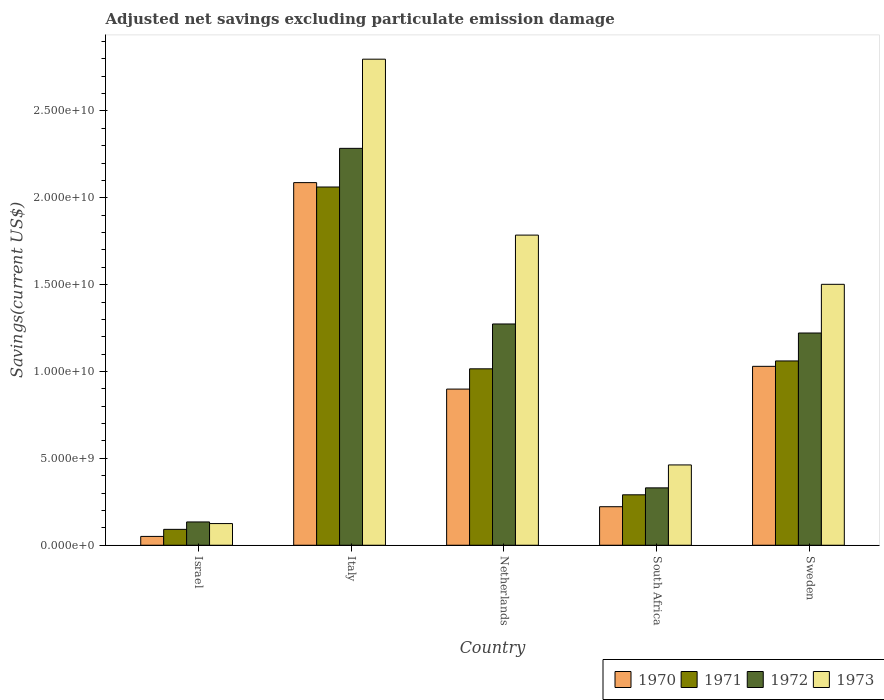Are the number of bars per tick equal to the number of legend labels?
Offer a terse response. Yes. Are the number of bars on each tick of the X-axis equal?
Your answer should be very brief. Yes. How many bars are there on the 2nd tick from the left?
Provide a succinct answer. 4. How many bars are there on the 2nd tick from the right?
Your response must be concise. 4. What is the label of the 5th group of bars from the left?
Offer a very short reply. Sweden. In how many cases, is the number of bars for a given country not equal to the number of legend labels?
Offer a very short reply. 0. What is the adjusted net savings in 1972 in Sweden?
Provide a short and direct response. 1.22e+1. Across all countries, what is the maximum adjusted net savings in 1970?
Provide a short and direct response. 2.09e+1. Across all countries, what is the minimum adjusted net savings in 1971?
Offer a terse response. 9.14e+08. What is the total adjusted net savings in 1973 in the graph?
Provide a succinct answer. 6.67e+1. What is the difference between the adjusted net savings in 1973 in Italy and that in South Africa?
Offer a very short reply. 2.34e+1. What is the difference between the adjusted net savings in 1972 in Israel and the adjusted net savings in 1970 in South Africa?
Provide a short and direct response. -8.77e+08. What is the average adjusted net savings in 1973 per country?
Your response must be concise. 1.33e+1. What is the difference between the adjusted net savings of/in 1972 and adjusted net savings of/in 1973 in Israel?
Provide a short and direct response. 9.40e+07. What is the ratio of the adjusted net savings in 1971 in South Africa to that in Sweden?
Give a very brief answer. 0.27. What is the difference between the highest and the second highest adjusted net savings in 1971?
Keep it short and to the point. -1.00e+1. What is the difference between the highest and the lowest adjusted net savings in 1972?
Your response must be concise. 2.15e+1. Is it the case that in every country, the sum of the adjusted net savings in 1971 and adjusted net savings in 1972 is greater than the sum of adjusted net savings in 1970 and adjusted net savings in 1973?
Make the answer very short. No. Is it the case that in every country, the sum of the adjusted net savings in 1971 and adjusted net savings in 1973 is greater than the adjusted net savings in 1970?
Make the answer very short. Yes. How many bars are there?
Offer a very short reply. 20. Are all the bars in the graph horizontal?
Ensure brevity in your answer.  No. How many countries are there in the graph?
Ensure brevity in your answer.  5. What is the difference between two consecutive major ticks on the Y-axis?
Offer a very short reply. 5.00e+09. Does the graph contain any zero values?
Provide a short and direct response. No. Does the graph contain grids?
Your answer should be compact. No. Where does the legend appear in the graph?
Provide a short and direct response. Bottom right. How are the legend labels stacked?
Your answer should be compact. Horizontal. What is the title of the graph?
Offer a terse response. Adjusted net savings excluding particulate emission damage. What is the label or title of the Y-axis?
Your answer should be compact. Savings(current US$). What is the Savings(current US$) in 1970 in Israel?
Offer a very short reply. 5.08e+08. What is the Savings(current US$) of 1971 in Israel?
Make the answer very short. 9.14e+08. What is the Savings(current US$) of 1972 in Israel?
Offer a very short reply. 1.34e+09. What is the Savings(current US$) in 1973 in Israel?
Offer a terse response. 1.25e+09. What is the Savings(current US$) of 1970 in Italy?
Provide a short and direct response. 2.09e+1. What is the Savings(current US$) of 1971 in Italy?
Make the answer very short. 2.06e+1. What is the Savings(current US$) of 1972 in Italy?
Ensure brevity in your answer.  2.28e+1. What is the Savings(current US$) of 1973 in Italy?
Ensure brevity in your answer.  2.80e+1. What is the Savings(current US$) in 1970 in Netherlands?
Offer a terse response. 8.99e+09. What is the Savings(current US$) in 1971 in Netherlands?
Your response must be concise. 1.02e+1. What is the Savings(current US$) in 1972 in Netherlands?
Your response must be concise. 1.27e+1. What is the Savings(current US$) in 1973 in Netherlands?
Offer a very short reply. 1.79e+1. What is the Savings(current US$) in 1970 in South Africa?
Your answer should be very brief. 2.22e+09. What is the Savings(current US$) in 1971 in South Africa?
Provide a short and direct response. 2.90e+09. What is the Savings(current US$) in 1972 in South Africa?
Your response must be concise. 3.30e+09. What is the Savings(current US$) in 1973 in South Africa?
Offer a very short reply. 4.62e+09. What is the Savings(current US$) of 1970 in Sweden?
Ensure brevity in your answer.  1.03e+1. What is the Savings(current US$) in 1971 in Sweden?
Offer a very short reply. 1.06e+1. What is the Savings(current US$) of 1972 in Sweden?
Provide a short and direct response. 1.22e+1. What is the Savings(current US$) in 1973 in Sweden?
Give a very brief answer. 1.50e+1. Across all countries, what is the maximum Savings(current US$) of 1970?
Your answer should be very brief. 2.09e+1. Across all countries, what is the maximum Savings(current US$) in 1971?
Keep it short and to the point. 2.06e+1. Across all countries, what is the maximum Savings(current US$) of 1972?
Ensure brevity in your answer.  2.28e+1. Across all countries, what is the maximum Savings(current US$) of 1973?
Your answer should be very brief. 2.80e+1. Across all countries, what is the minimum Savings(current US$) of 1970?
Offer a terse response. 5.08e+08. Across all countries, what is the minimum Savings(current US$) of 1971?
Give a very brief answer. 9.14e+08. Across all countries, what is the minimum Savings(current US$) in 1972?
Your response must be concise. 1.34e+09. Across all countries, what is the minimum Savings(current US$) of 1973?
Keep it short and to the point. 1.25e+09. What is the total Savings(current US$) of 1970 in the graph?
Make the answer very short. 4.29e+1. What is the total Savings(current US$) of 1971 in the graph?
Provide a succinct answer. 4.52e+1. What is the total Savings(current US$) in 1972 in the graph?
Provide a succinct answer. 5.24e+1. What is the total Savings(current US$) in 1973 in the graph?
Ensure brevity in your answer.  6.67e+1. What is the difference between the Savings(current US$) of 1970 in Israel and that in Italy?
Give a very brief answer. -2.04e+1. What is the difference between the Savings(current US$) of 1971 in Israel and that in Italy?
Provide a succinct answer. -1.97e+1. What is the difference between the Savings(current US$) in 1972 in Israel and that in Italy?
Offer a terse response. -2.15e+1. What is the difference between the Savings(current US$) of 1973 in Israel and that in Italy?
Provide a succinct answer. -2.67e+1. What is the difference between the Savings(current US$) in 1970 in Israel and that in Netherlands?
Provide a succinct answer. -8.48e+09. What is the difference between the Savings(current US$) of 1971 in Israel and that in Netherlands?
Ensure brevity in your answer.  -9.24e+09. What is the difference between the Savings(current US$) of 1972 in Israel and that in Netherlands?
Your answer should be very brief. -1.14e+1. What is the difference between the Savings(current US$) of 1973 in Israel and that in Netherlands?
Offer a terse response. -1.66e+1. What is the difference between the Savings(current US$) of 1970 in Israel and that in South Africa?
Your answer should be very brief. -1.71e+09. What is the difference between the Savings(current US$) of 1971 in Israel and that in South Africa?
Keep it short and to the point. -1.99e+09. What is the difference between the Savings(current US$) in 1972 in Israel and that in South Africa?
Make the answer very short. -1.96e+09. What is the difference between the Savings(current US$) of 1973 in Israel and that in South Africa?
Offer a terse response. -3.38e+09. What is the difference between the Savings(current US$) in 1970 in Israel and that in Sweden?
Provide a succinct answer. -9.79e+09. What is the difference between the Savings(current US$) of 1971 in Israel and that in Sweden?
Your response must be concise. -9.69e+09. What is the difference between the Savings(current US$) of 1972 in Israel and that in Sweden?
Offer a very short reply. -1.09e+1. What is the difference between the Savings(current US$) of 1973 in Israel and that in Sweden?
Your answer should be compact. -1.38e+1. What is the difference between the Savings(current US$) of 1970 in Italy and that in Netherlands?
Your response must be concise. 1.19e+1. What is the difference between the Savings(current US$) in 1971 in Italy and that in Netherlands?
Offer a terse response. 1.05e+1. What is the difference between the Savings(current US$) in 1972 in Italy and that in Netherlands?
Your answer should be compact. 1.01e+1. What is the difference between the Savings(current US$) in 1973 in Italy and that in Netherlands?
Ensure brevity in your answer.  1.01e+1. What is the difference between the Savings(current US$) of 1970 in Italy and that in South Africa?
Make the answer very short. 1.87e+1. What is the difference between the Savings(current US$) of 1971 in Italy and that in South Africa?
Your answer should be very brief. 1.77e+1. What is the difference between the Savings(current US$) of 1972 in Italy and that in South Africa?
Your answer should be compact. 1.95e+1. What is the difference between the Savings(current US$) of 1973 in Italy and that in South Africa?
Your response must be concise. 2.34e+1. What is the difference between the Savings(current US$) in 1970 in Italy and that in Sweden?
Provide a succinct answer. 1.06e+1. What is the difference between the Savings(current US$) of 1971 in Italy and that in Sweden?
Provide a short and direct response. 1.00e+1. What is the difference between the Savings(current US$) in 1972 in Italy and that in Sweden?
Your answer should be compact. 1.06e+1. What is the difference between the Savings(current US$) in 1973 in Italy and that in Sweden?
Give a very brief answer. 1.30e+1. What is the difference between the Savings(current US$) of 1970 in Netherlands and that in South Africa?
Offer a terse response. 6.77e+09. What is the difference between the Savings(current US$) of 1971 in Netherlands and that in South Africa?
Provide a succinct answer. 7.25e+09. What is the difference between the Savings(current US$) of 1972 in Netherlands and that in South Africa?
Your answer should be compact. 9.43e+09. What is the difference between the Savings(current US$) of 1973 in Netherlands and that in South Africa?
Make the answer very short. 1.32e+1. What is the difference between the Savings(current US$) in 1970 in Netherlands and that in Sweden?
Keep it short and to the point. -1.31e+09. What is the difference between the Savings(current US$) of 1971 in Netherlands and that in Sweden?
Offer a very short reply. -4.54e+08. What is the difference between the Savings(current US$) in 1972 in Netherlands and that in Sweden?
Provide a short and direct response. 5.20e+08. What is the difference between the Savings(current US$) in 1973 in Netherlands and that in Sweden?
Your answer should be very brief. 2.83e+09. What is the difference between the Savings(current US$) of 1970 in South Africa and that in Sweden?
Your response must be concise. -8.08e+09. What is the difference between the Savings(current US$) in 1971 in South Africa and that in Sweden?
Your answer should be very brief. -7.70e+09. What is the difference between the Savings(current US$) in 1972 in South Africa and that in Sweden?
Your answer should be very brief. -8.91e+09. What is the difference between the Savings(current US$) of 1973 in South Africa and that in Sweden?
Your response must be concise. -1.04e+1. What is the difference between the Savings(current US$) of 1970 in Israel and the Savings(current US$) of 1971 in Italy?
Offer a very short reply. -2.01e+1. What is the difference between the Savings(current US$) of 1970 in Israel and the Savings(current US$) of 1972 in Italy?
Your response must be concise. -2.23e+1. What is the difference between the Savings(current US$) in 1970 in Israel and the Savings(current US$) in 1973 in Italy?
Offer a terse response. -2.75e+1. What is the difference between the Savings(current US$) in 1971 in Israel and the Savings(current US$) in 1972 in Italy?
Offer a very short reply. -2.19e+1. What is the difference between the Savings(current US$) of 1971 in Israel and the Savings(current US$) of 1973 in Italy?
Your answer should be compact. -2.71e+1. What is the difference between the Savings(current US$) of 1972 in Israel and the Savings(current US$) of 1973 in Italy?
Keep it short and to the point. -2.66e+1. What is the difference between the Savings(current US$) of 1970 in Israel and the Savings(current US$) of 1971 in Netherlands?
Your answer should be compact. -9.65e+09. What is the difference between the Savings(current US$) in 1970 in Israel and the Savings(current US$) in 1972 in Netherlands?
Make the answer very short. -1.22e+1. What is the difference between the Savings(current US$) in 1970 in Israel and the Savings(current US$) in 1973 in Netherlands?
Your response must be concise. -1.73e+1. What is the difference between the Savings(current US$) of 1971 in Israel and the Savings(current US$) of 1972 in Netherlands?
Offer a terse response. -1.18e+1. What is the difference between the Savings(current US$) in 1971 in Israel and the Savings(current US$) in 1973 in Netherlands?
Your answer should be compact. -1.69e+1. What is the difference between the Savings(current US$) in 1972 in Israel and the Savings(current US$) in 1973 in Netherlands?
Your answer should be compact. -1.65e+1. What is the difference between the Savings(current US$) in 1970 in Israel and the Savings(current US$) in 1971 in South Africa?
Offer a terse response. -2.39e+09. What is the difference between the Savings(current US$) of 1970 in Israel and the Savings(current US$) of 1972 in South Africa?
Your response must be concise. -2.79e+09. What is the difference between the Savings(current US$) of 1970 in Israel and the Savings(current US$) of 1973 in South Africa?
Ensure brevity in your answer.  -4.11e+09. What is the difference between the Savings(current US$) in 1971 in Israel and the Savings(current US$) in 1972 in South Africa?
Ensure brevity in your answer.  -2.39e+09. What is the difference between the Savings(current US$) in 1971 in Israel and the Savings(current US$) in 1973 in South Africa?
Offer a very short reply. -3.71e+09. What is the difference between the Savings(current US$) of 1972 in Israel and the Savings(current US$) of 1973 in South Africa?
Offer a terse response. -3.28e+09. What is the difference between the Savings(current US$) in 1970 in Israel and the Savings(current US$) in 1971 in Sweden?
Your answer should be compact. -1.01e+1. What is the difference between the Savings(current US$) of 1970 in Israel and the Savings(current US$) of 1972 in Sweden?
Offer a very short reply. -1.17e+1. What is the difference between the Savings(current US$) in 1970 in Israel and the Savings(current US$) in 1973 in Sweden?
Ensure brevity in your answer.  -1.45e+1. What is the difference between the Savings(current US$) in 1971 in Israel and the Savings(current US$) in 1972 in Sweden?
Your answer should be compact. -1.13e+1. What is the difference between the Savings(current US$) of 1971 in Israel and the Savings(current US$) of 1973 in Sweden?
Your answer should be compact. -1.41e+1. What is the difference between the Savings(current US$) of 1972 in Israel and the Savings(current US$) of 1973 in Sweden?
Give a very brief answer. -1.37e+1. What is the difference between the Savings(current US$) of 1970 in Italy and the Savings(current US$) of 1971 in Netherlands?
Give a very brief answer. 1.07e+1. What is the difference between the Savings(current US$) of 1970 in Italy and the Savings(current US$) of 1972 in Netherlands?
Ensure brevity in your answer.  8.14e+09. What is the difference between the Savings(current US$) in 1970 in Italy and the Savings(current US$) in 1973 in Netherlands?
Your answer should be compact. 3.02e+09. What is the difference between the Savings(current US$) in 1971 in Italy and the Savings(current US$) in 1972 in Netherlands?
Offer a terse response. 7.88e+09. What is the difference between the Savings(current US$) in 1971 in Italy and the Savings(current US$) in 1973 in Netherlands?
Your answer should be very brief. 2.77e+09. What is the difference between the Savings(current US$) of 1972 in Italy and the Savings(current US$) of 1973 in Netherlands?
Give a very brief answer. 4.99e+09. What is the difference between the Savings(current US$) of 1970 in Italy and the Savings(current US$) of 1971 in South Africa?
Offer a very short reply. 1.80e+1. What is the difference between the Savings(current US$) of 1970 in Italy and the Savings(current US$) of 1972 in South Africa?
Your response must be concise. 1.76e+1. What is the difference between the Savings(current US$) of 1970 in Italy and the Savings(current US$) of 1973 in South Africa?
Your answer should be compact. 1.62e+1. What is the difference between the Savings(current US$) in 1971 in Italy and the Savings(current US$) in 1972 in South Africa?
Provide a succinct answer. 1.73e+1. What is the difference between the Savings(current US$) in 1971 in Italy and the Savings(current US$) in 1973 in South Africa?
Provide a short and direct response. 1.60e+1. What is the difference between the Savings(current US$) of 1972 in Italy and the Savings(current US$) of 1973 in South Africa?
Your response must be concise. 1.82e+1. What is the difference between the Savings(current US$) of 1970 in Italy and the Savings(current US$) of 1971 in Sweden?
Provide a succinct answer. 1.03e+1. What is the difference between the Savings(current US$) in 1970 in Italy and the Savings(current US$) in 1972 in Sweden?
Provide a short and direct response. 8.66e+09. What is the difference between the Savings(current US$) of 1970 in Italy and the Savings(current US$) of 1973 in Sweden?
Provide a short and direct response. 5.85e+09. What is the difference between the Savings(current US$) in 1971 in Italy and the Savings(current US$) in 1972 in Sweden?
Provide a succinct answer. 8.40e+09. What is the difference between the Savings(current US$) in 1971 in Italy and the Savings(current US$) in 1973 in Sweden?
Offer a very short reply. 5.60e+09. What is the difference between the Savings(current US$) in 1972 in Italy and the Savings(current US$) in 1973 in Sweden?
Your response must be concise. 7.83e+09. What is the difference between the Savings(current US$) in 1970 in Netherlands and the Savings(current US$) in 1971 in South Africa?
Ensure brevity in your answer.  6.09e+09. What is the difference between the Savings(current US$) in 1970 in Netherlands and the Savings(current US$) in 1972 in South Africa?
Keep it short and to the point. 5.69e+09. What is the difference between the Savings(current US$) of 1970 in Netherlands and the Savings(current US$) of 1973 in South Africa?
Provide a short and direct response. 4.37e+09. What is the difference between the Savings(current US$) in 1971 in Netherlands and the Savings(current US$) in 1972 in South Africa?
Provide a succinct answer. 6.85e+09. What is the difference between the Savings(current US$) in 1971 in Netherlands and the Savings(current US$) in 1973 in South Africa?
Your answer should be compact. 5.53e+09. What is the difference between the Savings(current US$) of 1972 in Netherlands and the Savings(current US$) of 1973 in South Africa?
Offer a very short reply. 8.11e+09. What is the difference between the Savings(current US$) in 1970 in Netherlands and the Savings(current US$) in 1971 in Sweden?
Your answer should be compact. -1.62e+09. What is the difference between the Savings(current US$) of 1970 in Netherlands and the Savings(current US$) of 1972 in Sweden?
Give a very brief answer. -3.23e+09. What is the difference between the Savings(current US$) of 1970 in Netherlands and the Savings(current US$) of 1973 in Sweden?
Give a very brief answer. -6.03e+09. What is the difference between the Savings(current US$) of 1971 in Netherlands and the Savings(current US$) of 1972 in Sweden?
Your response must be concise. -2.06e+09. What is the difference between the Savings(current US$) of 1971 in Netherlands and the Savings(current US$) of 1973 in Sweden?
Make the answer very short. -4.86e+09. What is the difference between the Savings(current US$) of 1972 in Netherlands and the Savings(current US$) of 1973 in Sweden?
Keep it short and to the point. -2.28e+09. What is the difference between the Savings(current US$) in 1970 in South Africa and the Savings(current US$) in 1971 in Sweden?
Your answer should be very brief. -8.39e+09. What is the difference between the Savings(current US$) in 1970 in South Africa and the Savings(current US$) in 1972 in Sweden?
Your response must be concise. -1.00e+1. What is the difference between the Savings(current US$) in 1970 in South Africa and the Savings(current US$) in 1973 in Sweden?
Give a very brief answer. -1.28e+1. What is the difference between the Savings(current US$) in 1971 in South Africa and the Savings(current US$) in 1972 in Sweden?
Your answer should be compact. -9.31e+09. What is the difference between the Savings(current US$) of 1971 in South Africa and the Savings(current US$) of 1973 in Sweden?
Your answer should be compact. -1.21e+1. What is the difference between the Savings(current US$) in 1972 in South Africa and the Savings(current US$) in 1973 in Sweden?
Offer a terse response. -1.17e+1. What is the average Savings(current US$) of 1970 per country?
Offer a terse response. 8.58e+09. What is the average Savings(current US$) in 1971 per country?
Provide a short and direct response. 9.04e+09. What is the average Savings(current US$) in 1972 per country?
Ensure brevity in your answer.  1.05e+1. What is the average Savings(current US$) in 1973 per country?
Offer a terse response. 1.33e+1. What is the difference between the Savings(current US$) in 1970 and Savings(current US$) in 1971 in Israel?
Your answer should be very brief. -4.06e+08. What is the difference between the Savings(current US$) in 1970 and Savings(current US$) in 1972 in Israel?
Keep it short and to the point. -8.33e+08. What is the difference between the Savings(current US$) of 1970 and Savings(current US$) of 1973 in Israel?
Ensure brevity in your answer.  -7.39e+08. What is the difference between the Savings(current US$) in 1971 and Savings(current US$) in 1972 in Israel?
Your answer should be compact. -4.27e+08. What is the difference between the Savings(current US$) in 1971 and Savings(current US$) in 1973 in Israel?
Make the answer very short. -3.33e+08. What is the difference between the Savings(current US$) of 1972 and Savings(current US$) of 1973 in Israel?
Give a very brief answer. 9.40e+07. What is the difference between the Savings(current US$) of 1970 and Savings(current US$) of 1971 in Italy?
Your answer should be compact. 2.53e+08. What is the difference between the Savings(current US$) in 1970 and Savings(current US$) in 1972 in Italy?
Give a very brief answer. -1.97e+09. What is the difference between the Savings(current US$) of 1970 and Savings(current US$) of 1973 in Italy?
Offer a very short reply. -7.11e+09. What is the difference between the Savings(current US$) of 1971 and Savings(current US$) of 1972 in Italy?
Offer a terse response. -2.23e+09. What is the difference between the Savings(current US$) in 1971 and Savings(current US$) in 1973 in Italy?
Ensure brevity in your answer.  -7.36e+09. What is the difference between the Savings(current US$) in 1972 and Savings(current US$) in 1973 in Italy?
Provide a succinct answer. -5.13e+09. What is the difference between the Savings(current US$) of 1970 and Savings(current US$) of 1971 in Netherlands?
Ensure brevity in your answer.  -1.17e+09. What is the difference between the Savings(current US$) in 1970 and Savings(current US$) in 1972 in Netherlands?
Make the answer very short. -3.75e+09. What is the difference between the Savings(current US$) of 1970 and Savings(current US$) of 1973 in Netherlands?
Keep it short and to the point. -8.86e+09. What is the difference between the Savings(current US$) in 1971 and Savings(current US$) in 1972 in Netherlands?
Provide a succinct answer. -2.58e+09. What is the difference between the Savings(current US$) of 1971 and Savings(current US$) of 1973 in Netherlands?
Make the answer very short. -7.70e+09. What is the difference between the Savings(current US$) of 1972 and Savings(current US$) of 1973 in Netherlands?
Give a very brief answer. -5.11e+09. What is the difference between the Savings(current US$) of 1970 and Savings(current US$) of 1971 in South Africa?
Give a very brief answer. -6.85e+08. What is the difference between the Savings(current US$) in 1970 and Savings(current US$) in 1972 in South Africa?
Provide a short and direct response. -1.08e+09. What is the difference between the Savings(current US$) of 1970 and Savings(current US$) of 1973 in South Africa?
Your answer should be very brief. -2.40e+09. What is the difference between the Savings(current US$) of 1971 and Savings(current US$) of 1972 in South Africa?
Offer a very short reply. -4.00e+08. What is the difference between the Savings(current US$) of 1971 and Savings(current US$) of 1973 in South Africa?
Ensure brevity in your answer.  -1.72e+09. What is the difference between the Savings(current US$) in 1972 and Savings(current US$) in 1973 in South Africa?
Offer a very short reply. -1.32e+09. What is the difference between the Savings(current US$) of 1970 and Savings(current US$) of 1971 in Sweden?
Provide a succinct answer. -3.10e+08. What is the difference between the Savings(current US$) in 1970 and Savings(current US$) in 1972 in Sweden?
Give a very brief answer. -1.92e+09. What is the difference between the Savings(current US$) of 1970 and Savings(current US$) of 1973 in Sweden?
Offer a terse response. -4.72e+09. What is the difference between the Savings(current US$) in 1971 and Savings(current US$) in 1972 in Sweden?
Offer a very short reply. -1.61e+09. What is the difference between the Savings(current US$) of 1971 and Savings(current US$) of 1973 in Sweden?
Offer a terse response. -4.41e+09. What is the difference between the Savings(current US$) in 1972 and Savings(current US$) in 1973 in Sweden?
Offer a terse response. -2.80e+09. What is the ratio of the Savings(current US$) of 1970 in Israel to that in Italy?
Provide a succinct answer. 0.02. What is the ratio of the Savings(current US$) of 1971 in Israel to that in Italy?
Provide a short and direct response. 0.04. What is the ratio of the Savings(current US$) in 1972 in Israel to that in Italy?
Make the answer very short. 0.06. What is the ratio of the Savings(current US$) in 1973 in Israel to that in Italy?
Ensure brevity in your answer.  0.04. What is the ratio of the Savings(current US$) of 1970 in Israel to that in Netherlands?
Provide a short and direct response. 0.06. What is the ratio of the Savings(current US$) in 1971 in Israel to that in Netherlands?
Provide a succinct answer. 0.09. What is the ratio of the Savings(current US$) of 1972 in Israel to that in Netherlands?
Your answer should be very brief. 0.11. What is the ratio of the Savings(current US$) in 1973 in Israel to that in Netherlands?
Keep it short and to the point. 0.07. What is the ratio of the Savings(current US$) in 1970 in Israel to that in South Africa?
Your answer should be very brief. 0.23. What is the ratio of the Savings(current US$) in 1971 in Israel to that in South Africa?
Give a very brief answer. 0.32. What is the ratio of the Savings(current US$) in 1972 in Israel to that in South Africa?
Keep it short and to the point. 0.41. What is the ratio of the Savings(current US$) in 1973 in Israel to that in South Africa?
Offer a very short reply. 0.27. What is the ratio of the Savings(current US$) in 1970 in Israel to that in Sweden?
Offer a very short reply. 0.05. What is the ratio of the Savings(current US$) in 1971 in Israel to that in Sweden?
Your answer should be compact. 0.09. What is the ratio of the Savings(current US$) of 1972 in Israel to that in Sweden?
Your answer should be very brief. 0.11. What is the ratio of the Savings(current US$) of 1973 in Israel to that in Sweden?
Your answer should be compact. 0.08. What is the ratio of the Savings(current US$) in 1970 in Italy to that in Netherlands?
Your response must be concise. 2.32. What is the ratio of the Savings(current US$) of 1971 in Italy to that in Netherlands?
Your response must be concise. 2.03. What is the ratio of the Savings(current US$) of 1972 in Italy to that in Netherlands?
Your response must be concise. 1.79. What is the ratio of the Savings(current US$) in 1973 in Italy to that in Netherlands?
Make the answer very short. 1.57. What is the ratio of the Savings(current US$) in 1970 in Italy to that in South Africa?
Ensure brevity in your answer.  9.41. What is the ratio of the Savings(current US$) in 1971 in Italy to that in South Africa?
Give a very brief answer. 7.1. What is the ratio of the Savings(current US$) in 1972 in Italy to that in South Africa?
Ensure brevity in your answer.  6.92. What is the ratio of the Savings(current US$) of 1973 in Italy to that in South Africa?
Give a very brief answer. 6.05. What is the ratio of the Savings(current US$) of 1970 in Italy to that in Sweden?
Provide a succinct answer. 2.03. What is the ratio of the Savings(current US$) of 1971 in Italy to that in Sweden?
Your response must be concise. 1.94. What is the ratio of the Savings(current US$) in 1972 in Italy to that in Sweden?
Your response must be concise. 1.87. What is the ratio of the Savings(current US$) in 1973 in Italy to that in Sweden?
Offer a terse response. 1.86. What is the ratio of the Savings(current US$) of 1970 in Netherlands to that in South Africa?
Give a very brief answer. 4.05. What is the ratio of the Savings(current US$) of 1971 in Netherlands to that in South Africa?
Give a very brief answer. 3.5. What is the ratio of the Savings(current US$) of 1972 in Netherlands to that in South Africa?
Give a very brief answer. 3.86. What is the ratio of the Savings(current US$) in 1973 in Netherlands to that in South Africa?
Provide a short and direct response. 3.86. What is the ratio of the Savings(current US$) in 1970 in Netherlands to that in Sweden?
Your response must be concise. 0.87. What is the ratio of the Savings(current US$) in 1971 in Netherlands to that in Sweden?
Keep it short and to the point. 0.96. What is the ratio of the Savings(current US$) of 1972 in Netherlands to that in Sweden?
Offer a terse response. 1.04. What is the ratio of the Savings(current US$) of 1973 in Netherlands to that in Sweden?
Give a very brief answer. 1.19. What is the ratio of the Savings(current US$) in 1970 in South Africa to that in Sweden?
Offer a very short reply. 0.22. What is the ratio of the Savings(current US$) in 1971 in South Africa to that in Sweden?
Your answer should be very brief. 0.27. What is the ratio of the Savings(current US$) of 1972 in South Africa to that in Sweden?
Offer a very short reply. 0.27. What is the ratio of the Savings(current US$) of 1973 in South Africa to that in Sweden?
Give a very brief answer. 0.31. What is the difference between the highest and the second highest Savings(current US$) of 1970?
Offer a terse response. 1.06e+1. What is the difference between the highest and the second highest Savings(current US$) in 1971?
Provide a succinct answer. 1.00e+1. What is the difference between the highest and the second highest Savings(current US$) in 1972?
Make the answer very short. 1.01e+1. What is the difference between the highest and the second highest Savings(current US$) of 1973?
Keep it short and to the point. 1.01e+1. What is the difference between the highest and the lowest Savings(current US$) in 1970?
Your answer should be compact. 2.04e+1. What is the difference between the highest and the lowest Savings(current US$) of 1971?
Give a very brief answer. 1.97e+1. What is the difference between the highest and the lowest Savings(current US$) of 1972?
Give a very brief answer. 2.15e+1. What is the difference between the highest and the lowest Savings(current US$) of 1973?
Provide a succinct answer. 2.67e+1. 